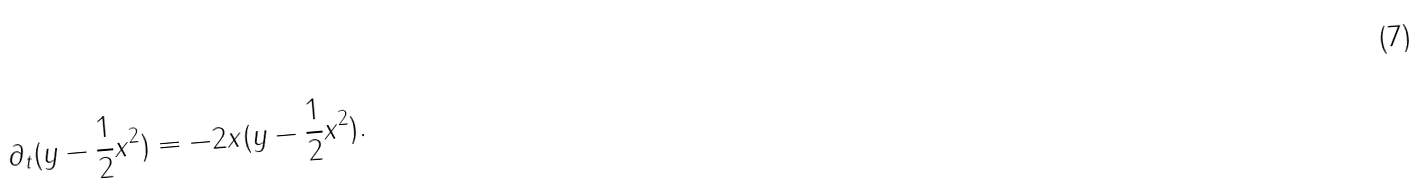<formula> <loc_0><loc_0><loc_500><loc_500>\partial _ { t } ( y - \frac { 1 } { 2 } x ^ { 2 } ) = - 2 x ( y - \frac { 1 } { 2 } x ^ { 2 } ) .</formula> 